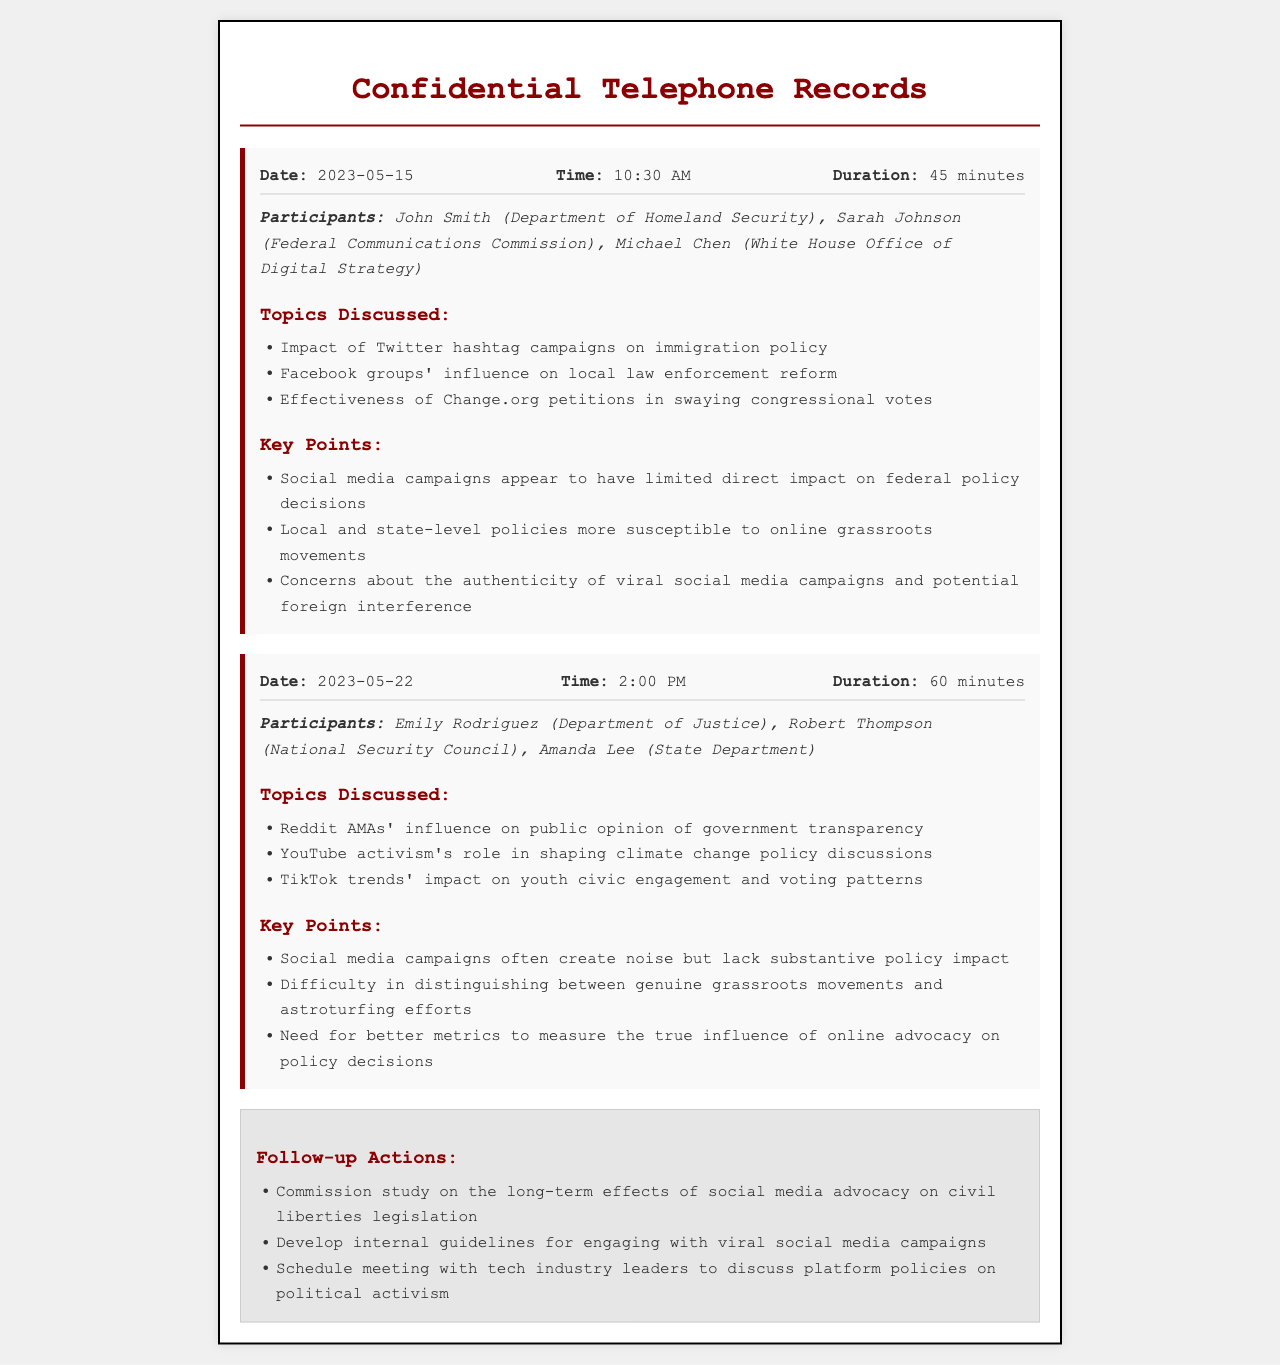What was the date of the first call? The first call took place on May 15, 2023.
Answer: May 15, 2023 Who participated in the second call? The participants of the second call included Emily Rodriguez, Robert Thompson, and Amanda Lee.
Answer: Emily Rodriguez, Robert Thompson, Amanda Lee What topic was discussed related to TikTok? The discussion included the impact of TikTok trends on youth civic engagement and voting patterns.
Answer: TikTok trends' impact on youth civic engagement and voting patterns How long was the duration of the first call? The duration of the first call was specified as 45 minutes.
Answer: 45 minutes What concern was raised about social media campaigns? A concern was raised about the authenticity of viral social media campaigns and potential foreign interference.
Answer: Authenticity of viral social media campaigns and potential foreign interference What action was decided for further study? There was a decision to commission a study on the long-term effects of social media advocacy on civil liberties legislation.
Answer: Commission study on the long-term effects of social media advocacy on civil liberties legislation What is one difficulty mentioned regarding social media campaigns? A difficulty mentioned is distinguishing between genuine grassroots movements and astroturfing efforts.
Answer: Distinguishing between genuine grassroots movements and astroturfing efforts What was the focus of the call on May 22, 2023? The focus of the call included discussions on Reddit AMAs' influence on public opinion of government transparency.
Answer: Reddit AMAs' influence on public opinion of government transparency How many participants were in the first call? The first call had three participants: John Smith, Sarah Johnson, and Michael Chen.
Answer: Three participants 